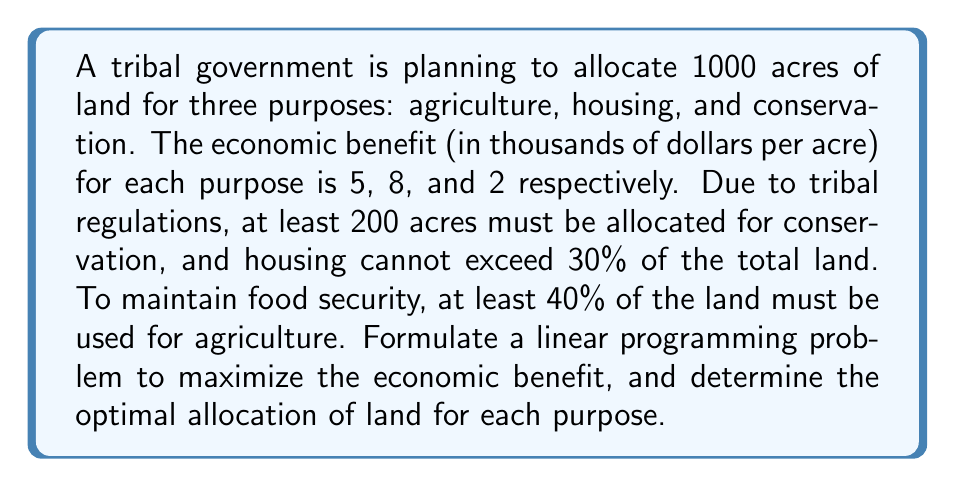Solve this math problem. Let's approach this problem step by step using linear programming:

1) Define variables:
   Let $x_1$ = acres for agriculture
   Let $x_2$ = acres for housing
   Let $x_3$ = acres for conservation

2) Objective function:
   Maximize $Z = 5x_1 + 8x_2 + 2x_3$

3) Constraints:
   a) Total land constraint: $x_1 + x_2 + x_3 = 1000$
   b) Conservation minimum: $x_3 \geq 200$
   c) Housing maximum: $x_2 \leq 0.3(1000) = 300$
   d) Agriculture minimum: $x_1 \geq 0.4(1000) = 400$
   e) Non-negativity: $x_1, x_2, x_3 \geq 0$

4) Solve using the simplex method or linear programming software:

   The optimal solution is:
   $x_1 = 500$ (agriculture)
   $x_2 = 300$ (housing)
   $x_3 = 200$ (conservation)

5) Verify constraints:
   a) 500 + 300 + 200 = 1000 (satisfied)
   b) 200 ≥ 200 (satisfied)
   c) 300 ≤ 300 (satisfied)
   d) 500 ≥ 400 (satisfied)
   e) All values are non-negative (satisfied)

6) Calculate maximum economic benefit:
   $Z = 5(500) + 8(300) + 2(200) = 5100$ thousand dollars

This solution maximizes the economic benefit while satisfying all constraints.
Answer: The optimal land allocation is 500 acres for agriculture, 300 acres for housing, and 200 acres for conservation. This allocation yields a maximum economic benefit of $5,100,000. 